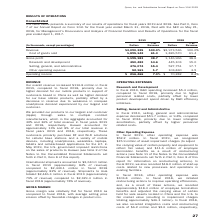From Qorvo's financial document, What are the company's respective revenue in 2018 and 2019? The document shows two values: $2,973,536 and $3,090,325 (in thousands). From the document: "Revenue $3,090,325 100.0% $2,973,536 100.0% Cost of goods sold 1,895,142 61.3 1,826,570 61.4 Revenue $3,090,325 100.0% $2,973,536 100.0% Cost of goods..." Also, What are the company's respective cost of goods sold in 2018 and 2019? The document shows two values: 1,826,570 and 1,895,142 (in thousands). From the document: ",973,536 100.0% Cost of goods sold 1,895,142 61.3 1,826,570 61.4 0,325 100.0% $2,973,536 100.0% Cost of goods sold 1,895,142 61.3 1,826,570 61.4..." Also, What are the company's respective gross profit in 2018 and 2019? The document shows two values: 1,146,966 and 1,195,183 (in thousands). From the document: "Gross profit 1,195,183 38.7 1,146,966 38.6 Research and development 450,482 14.6 445,103 15.0 Selling, general, and administrative 476,07 Gross profit..." Also, can you calculate: What is the company's average revenue in 2018 and 2019? To answer this question, I need to perform calculations using the financial data. The calculation is: ($2,973,536 + $3,090,325)/2 , which equals 3031930.5 (in thousands). This is based on the information: "Revenue $3,090,325 100.0% $2,973,536 100.0% Cost of goods sold 1,895,142 61.3 1,826,570 61.4 Revenue $3,090,325 100.0% $2,973,536 100.0% Cost of goods sold 1,895,142 61.3 1,826,570 61.4..." The key data points involved are: 2,973,536, 3,090,325. Also, can you calculate: What is the company's average cost of goods sold in 2018 and 2019? To answer this question, I need to perform calculations using the financial data. The calculation is: (1,826,570 + 1,895,142)/2 , which equals 1860856 (in thousands). This is based on the information: ",973,536 100.0% Cost of goods sold 1,895,142 61.3 1,826,570 61.4 0,325 100.0% $2,973,536 100.0% Cost of goods sold 1,895,142 61.3 1,826,570 61.4..." The key data points involved are: 1,826,570, 1,895,142. Also, can you calculate: What is the company's average gross profit in 2018 and 2019? To answer this question, I need to perform calculations using the financial data. The calculation is: (1,146,966 + 1,195,183)/2 , which equals 1171074.5 (in thousands). This is based on the information: "Gross profit 1,195,183 38.7 1,146,966 38.6 Research and development 450,482 14.6 445,103 15.0 Selling, general, and administrative 476,07 Gross profit 1,195,183 38.7 1,146,966 38.6 Research and develo..." The key data points involved are: 1,146,966, 1,195,183. 